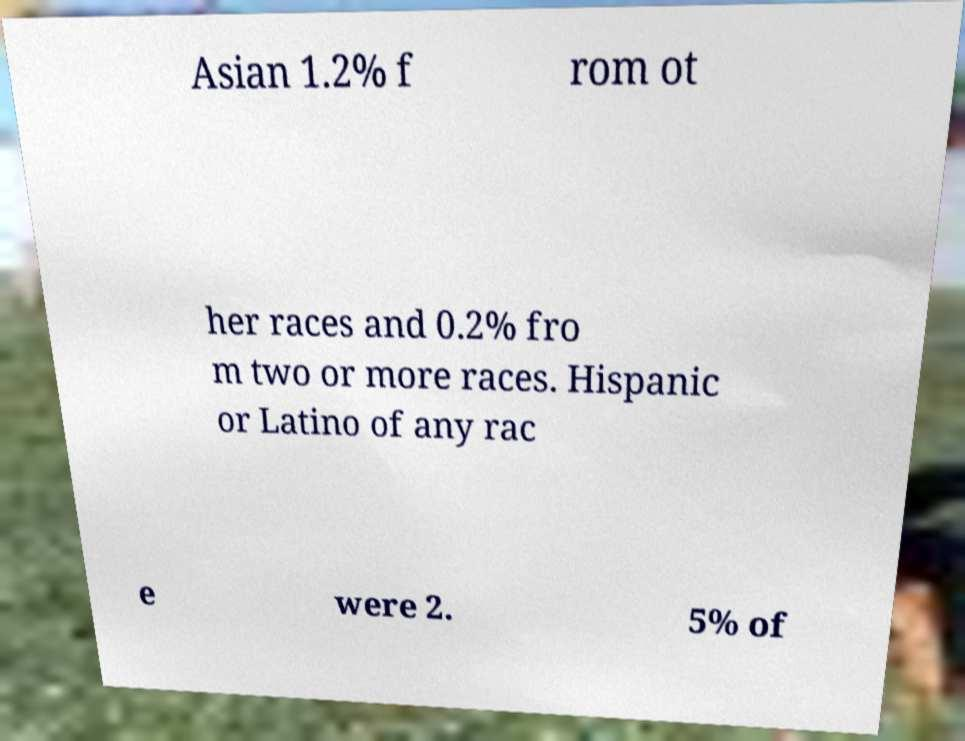What messages or text are displayed in this image? I need them in a readable, typed format. Asian 1.2% f rom ot her races and 0.2% fro m two or more races. Hispanic or Latino of any rac e were 2. 5% of 